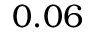<formula> <loc_0><loc_0><loc_500><loc_500>0 . 0 6</formula> 